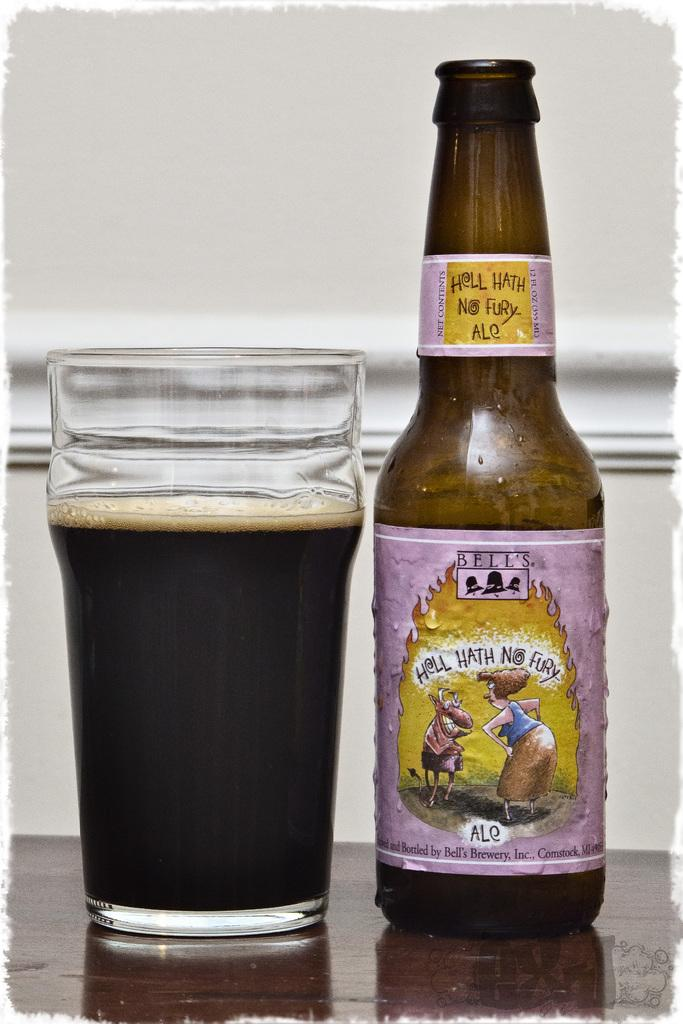What is present in the image that can hold a liquid? There is a glass and a bottle in the image. What can be observed about the bottle? The bottle has a label, which is pink in color, and there is a woman depicted on the bottle. Where are the glass and bottle located in the image? The glass and bottle are on a table. Who is present in the image? A man is standing in the image. How many legs can be seen on the cows in the image? There are no cows present in the image. What type of punishment is being administered to the man in the image? There is no indication of any punishment being administered to the man in the image. 